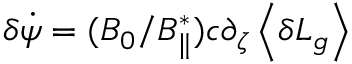<formula> <loc_0><loc_0><loc_500><loc_500>\delta \dot { \psi } = ( B _ { 0 } / B _ { \| } ^ { * } ) c \partial _ { \zeta } \left \langle \delta L _ { g } \right \rangle</formula> 